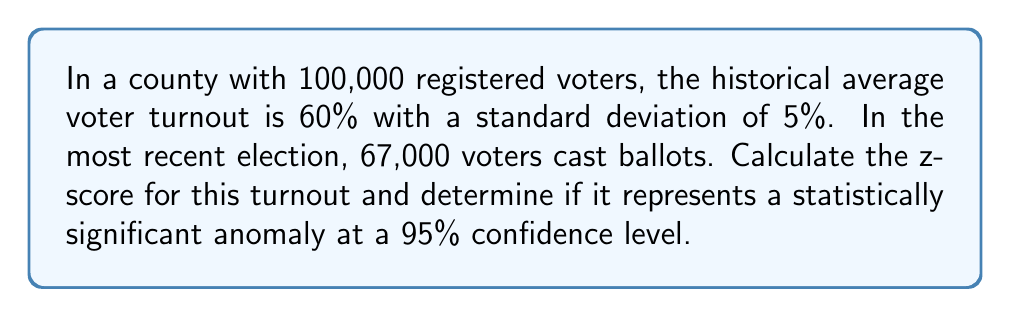Show me your answer to this math problem. To determine if the voter turnout is statistically significant, we'll calculate the z-score and compare it to the critical value for a 95% confidence level.

Step 1: Calculate the expected number of voters based on historical data.
Expected voters = 100,000 × 0.60 = 60,000

Step 2: Calculate the standard deviation in number of voters.
$\sigma = 100,000 \times 0.05 = 5,000$

Step 3: Calculate the z-score using the formula:
$$z = \frac{x - \mu}{\sigma}$$
Where:
$x$ = observed value (67,000)
$\mu$ = expected value (60,000)
$\sigma$ = standard deviation (5,000)

$$z = \frac{67,000 - 60,000}{5,000} = \frac{7,000}{5,000} = 1.4$$

Step 4: Determine the critical z-value for a 95% confidence level (two-tailed test).
The critical z-value for a 95% confidence level is ±1.96.

Step 5: Compare the calculated z-score to the critical value.
Since 1.4 < 1.96, the observed turnout is not statistically significant at the 95% confidence level.
Answer: z-score = 1.4; Not statistically significant at 95% confidence level 